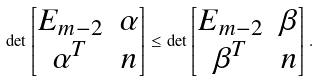Convert formula to latex. <formula><loc_0><loc_0><loc_500><loc_500>\det \begin{bmatrix} E _ { m - 2 } & \alpha \\ \alpha ^ { T } & n \end{bmatrix} \leq \det \begin{bmatrix} E _ { m - 2 } & \beta \\ \beta ^ { T } & n \end{bmatrix} .</formula> 